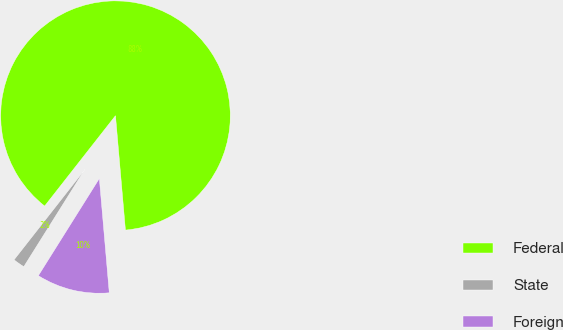Convert chart. <chart><loc_0><loc_0><loc_500><loc_500><pie_chart><fcel>Federal<fcel>State<fcel>Foreign<nl><fcel>88.04%<fcel>1.66%<fcel>10.3%<nl></chart> 